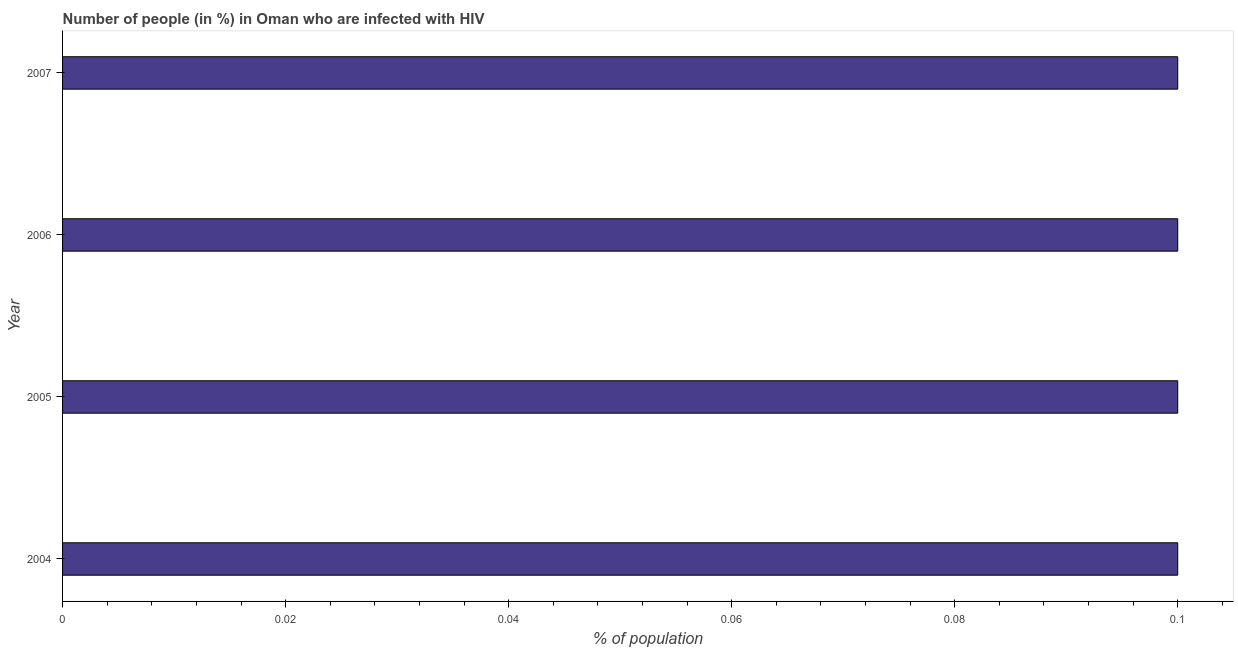What is the title of the graph?
Provide a succinct answer. Number of people (in %) in Oman who are infected with HIV. What is the label or title of the X-axis?
Provide a succinct answer. % of population. What is the number of people infected with hiv in 2007?
Give a very brief answer. 0.1. Across all years, what is the maximum number of people infected with hiv?
Offer a terse response. 0.1. In which year was the number of people infected with hiv maximum?
Provide a succinct answer. 2004. In which year was the number of people infected with hiv minimum?
Offer a terse response. 2004. What is the sum of the number of people infected with hiv?
Offer a very short reply. 0.4. What is the difference between the number of people infected with hiv in 2004 and 2005?
Your answer should be compact. 0. Is the difference between the number of people infected with hiv in 2004 and 2007 greater than the difference between any two years?
Ensure brevity in your answer.  Yes. What is the difference between the highest and the lowest number of people infected with hiv?
Give a very brief answer. 0. In how many years, is the number of people infected with hiv greater than the average number of people infected with hiv taken over all years?
Offer a very short reply. 0. How many bars are there?
Your response must be concise. 4. Are all the bars in the graph horizontal?
Your response must be concise. Yes. How many years are there in the graph?
Your answer should be very brief. 4. Are the values on the major ticks of X-axis written in scientific E-notation?
Provide a succinct answer. No. What is the % of population of 2006?
Your answer should be very brief. 0.1. What is the % of population in 2007?
Make the answer very short. 0.1. What is the difference between the % of population in 2004 and 2006?
Ensure brevity in your answer.  0. What is the difference between the % of population in 2004 and 2007?
Offer a very short reply. 0. What is the difference between the % of population in 2006 and 2007?
Your answer should be very brief. 0. What is the ratio of the % of population in 2004 to that in 2006?
Ensure brevity in your answer.  1. 